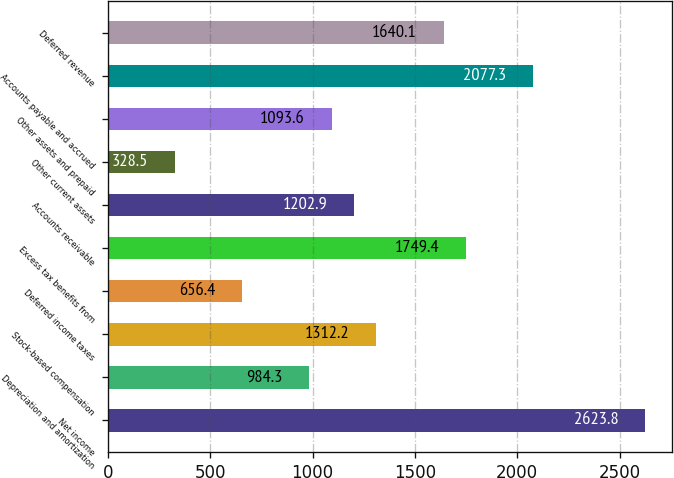Convert chart to OTSL. <chart><loc_0><loc_0><loc_500><loc_500><bar_chart><fcel>Net income<fcel>Depreciation and amortization<fcel>Stock-based compensation<fcel>Deferred income taxes<fcel>Excess tax benefits from<fcel>Accounts receivable<fcel>Other current assets<fcel>Other assets and prepaid<fcel>Accounts payable and accrued<fcel>Deferred revenue<nl><fcel>2623.8<fcel>984.3<fcel>1312.2<fcel>656.4<fcel>1749.4<fcel>1202.9<fcel>328.5<fcel>1093.6<fcel>2077.3<fcel>1640.1<nl></chart> 